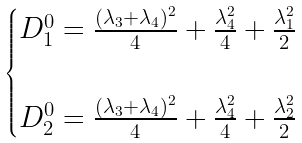<formula> <loc_0><loc_0><loc_500><loc_500>\begin{cases} D ^ { 0 } _ { 1 } = \frac { ( \lambda _ { 3 } + \lambda _ { 4 } ) ^ { 2 } } { 4 } + \frac { \lambda _ { 4 } ^ { 2 } } { 4 } + \frac { \lambda _ { 1 } ^ { 2 } } { 2 } \\ \\ D ^ { 0 } _ { 2 } = \frac { ( \lambda _ { 3 } + \lambda _ { 4 } ) ^ { 2 } } { 4 } + \frac { \lambda _ { 4 } ^ { 2 } } { 4 } + \frac { \lambda _ { 2 } ^ { 2 } } { 2 } \end{cases}</formula> 